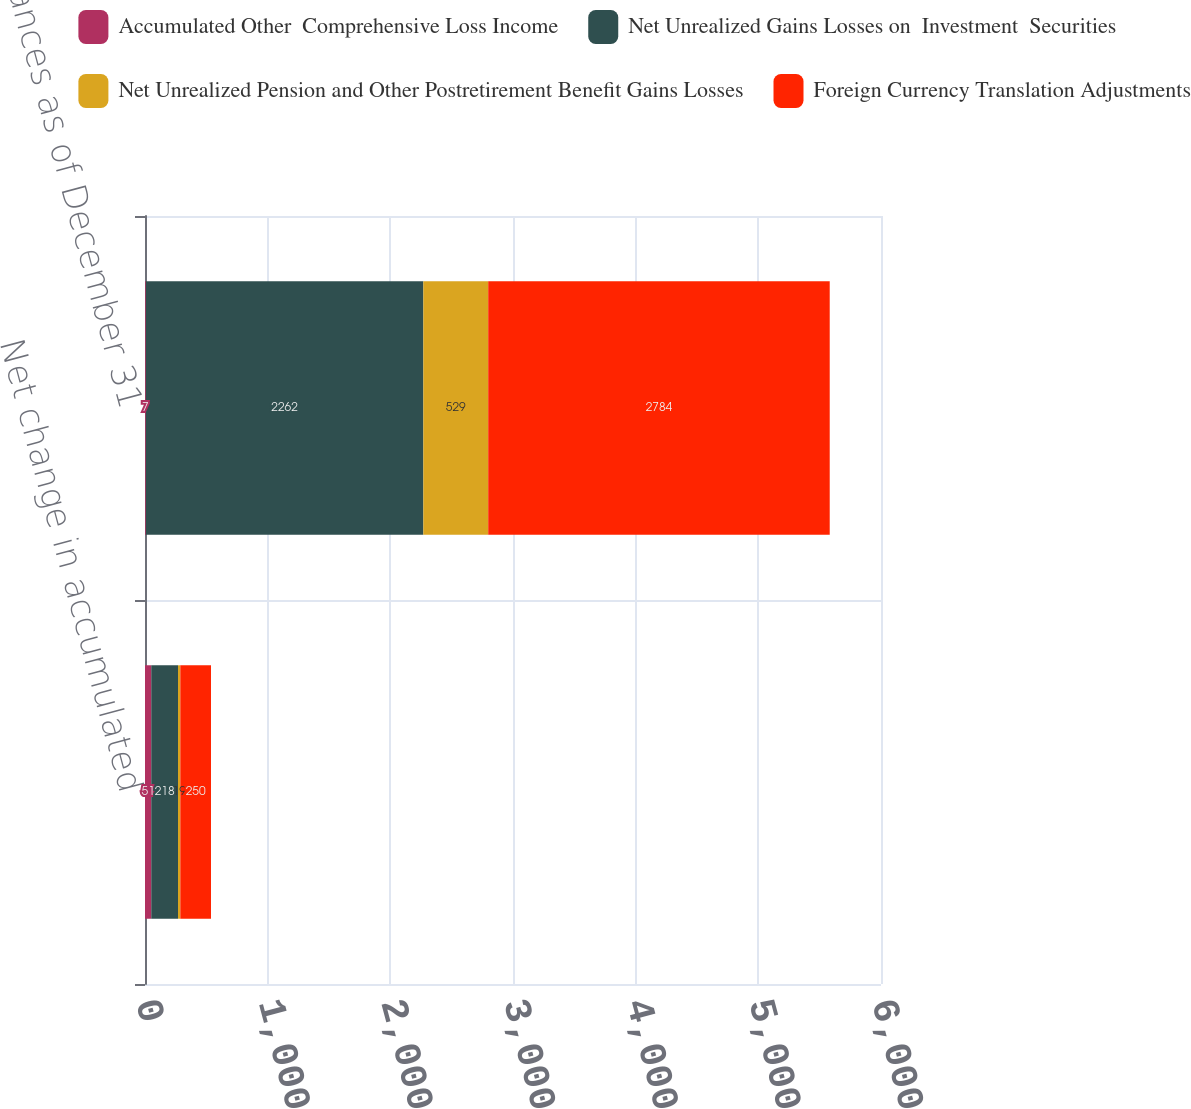<chart> <loc_0><loc_0><loc_500><loc_500><stacked_bar_chart><ecel><fcel>Net change in accumulated<fcel>Balances as of December 31<nl><fcel>Accumulated Other  Comprehensive Loss Income<fcel>51<fcel>7<nl><fcel>Net Unrealized Gains Losses on  Investment  Securities<fcel>218<fcel>2262<nl><fcel>Net Unrealized Pension and Other Postretirement Benefit Gains Losses<fcel>19<fcel>529<nl><fcel>Foreign Currency Translation Adjustments<fcel>250<fcel>2784<nl></chart> 